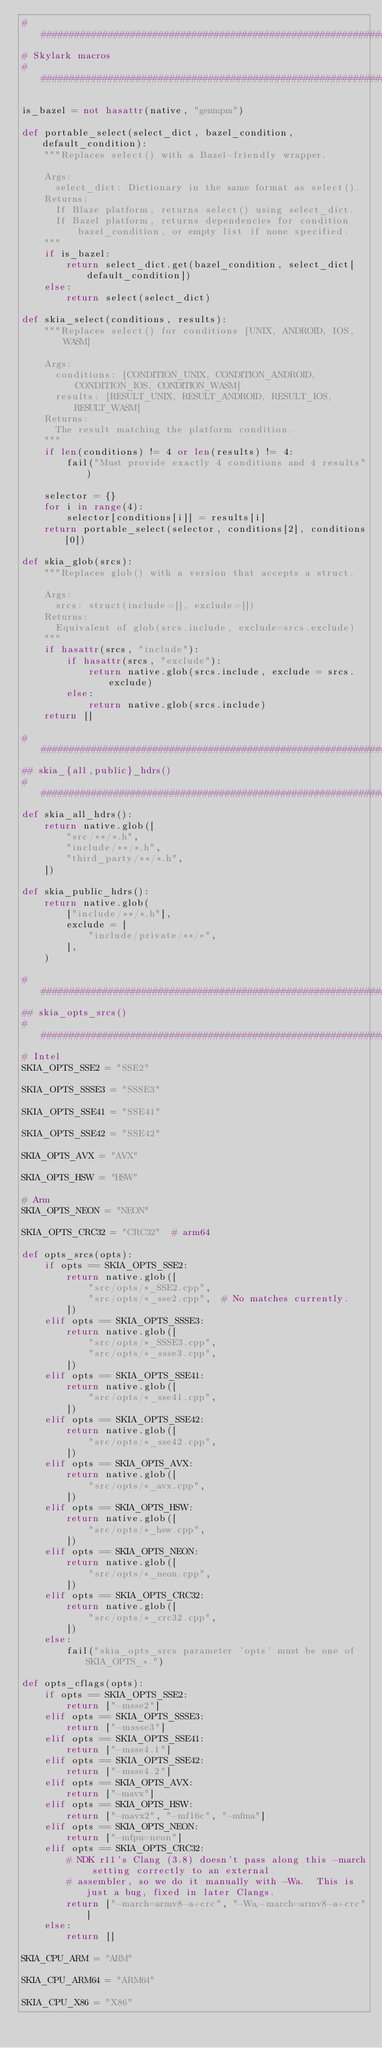<code> <loc_0><loc_0><loc_500><loc_500><_Python_>################################################################################
# Skylark macros
################################################################################

is_bazel = not hasattr(native, "genmpm")

def portable_select(select_dict, bazel_condition, default_condition):
    """Replaces select() with a Bazel-friendly wrapper.

    Args:
      select_dict: Dictionary in the same format as select().
    Returns:
      If Blaze platform, returns select() using select_dict.
      If Bazel platform, returns dependencies for condition
          bazel_condition, or empty list if none specified.
    """
    if is_bazel:
        return select_dict.get(bazel_condition, select_dict[default_condition])
    else:
        return select(select_dict)

def skia_select(conditions, results):
    """Replaces select() for conditions [UNIX, ANDROID, IOS, WASM]

    Args:
      conditions: [CONDITION_UNIX, CONDITION_ANDROID, CONDITION_IOS, CONDITION_WASM]
      results: [RESULT_UNIX, RESULT_ANDROID, RESULT_IOS, RESULT_WASM]
    Returns:
      The result matching the platform condition.
    """
    if len(conditions) != 4 or len(results) != 4:
        fail("Must provide exactly 4 conditions and 4 results")

    selector = {}
    for i in range(4):
        selector[conditions[i]] = results[i]
    return portable_select(selector, conditions[2], conditions[0])

def skia_glob(srcs):
    """Replaces glob() with a version that accepts a struct.

    Args:
      srcs: struct(include=[], exclude=[])
    Returns:
      Equivalent of glob(srcs.include, exclude=srcs.exclude)
    """
    if hasattr(srcs, "include"):
        if hasattr(srcs, "exclude"):
            return native.glob(srcs.include, exclude = srcs.exclude)
        else:
            return native.glob(srcs.include)
    return []

################################################################################
## skia_{all,public}_hdrs()
################################################################################
def skia_all_hdrs():
    return native.glob([
        "src/**/*.h",
        "include/**/*.h",
        "third_party/**/*.h",
    ])

def skia_public_hdrs():
    return native.glob(
        ["include/**/*.h"],
        exclude = [
            "include/private/**/*",
        ],
    )

################################################################################
## skia_opts_srcs()
################################################################################
# Intel
SKIA_OPTS_SSE2 = "SSE2"

SKIA_OPTS_SSSE3 = "SSSE3"

SKIA_OPTS_SSE41 = "SSE41"

SKIA_OPTS_SSE42 = "SSE42"

SKIA_OPTS_AVX = "AVX"

SKIA_OPTS_HSW = "HSW"

# Arm
SKIA_OPTS_NEON = "NEON"

SKIA_OPTS_CRC32 = "CRC32"  # arm64

def opts_srcs(opts):
    if opts == SKIA_OPTS_SSE2:
        return native.glob([
            "src/opts/*_SSE2.cpp",
            "src/opts/*_sse2.cpp",  # No matches currently.
        ])
    elif opts == SKIA_OPTS_SSSE3:
        return native.glob([
            "src/opts/*_SSSE3.cpp",
            "src/opts/*_ssse3.cpp",
        ])
    elif opts == SKIA_OPTS_SSE41:
        return native.glob([
            "src/opts/*_sse41.cpp",
        ])
    elif opts == SKIA_OPTS_SSE42:
        return native.glob([
            "src/opts/*_sse42.cpp",
        ])
    elif opts == SKIA_OPTS_AVX:
        return native.glob([
            "src/opts/*_avx.cpp",
        ])
    elif opts == SKIA_OPTS_HSW:
        return native.glob([
            "src/opts/*_hsw.cpp",
        ])
    elif opts == SKIA_OPTS_NEON:
        return native.glob([
            "src/opts/*_neon.cpp",
        ])
    elif opts == SKIA_OPTS_CRC32:
        return native.glob([
            "src/opts/*_crc32.cpp",
        ])
    else:
        fail("skia_opts_srcs parameter 'opts' must be one of SKIA_OPTS_*.")

def opts_cflags(opts):
    if opts == SKIA_OPTS_SSE2:
        return ["-msse2"]
    elif opts == SKIA_OPTS_SSSE3:
        return ["-mssse3"]
    elif opts == SKIA_OPTS_SSE41:
        return ["-msse4.1"]
    elif opts == SKIA_OPTS_SSE42:
        return ["-msse4.2"]
    elif opts == SKIA_OPTS_AVX:
        return ["-mavx"]
    elif opts == SKIA_OPTS_HSW:
        return ["-mavx2", "-mf16c", "-mfma"]
    elif opts == SKIA_OPTS_NEON:
        return ["-mfpu=neon"]
    elif opts == SKIA_OPTS_CRC32:
        # NDK r11's Clang (3.8) doesn't pass along this -march setting correctly to an external
        # assembler, so we do it manually with -Wa.  This is just a bug, fixed in later Clangs.
        return ["-march=armv8-a+crc", "-Wa,-march=armv8-a+crc"]
    else:
        return []

SKIA_CPU_ARM = "ARM"

SKIA_CPU_ARM64 = "ARM64"

SKIA_CPU_X86 = "X86"
</code> 